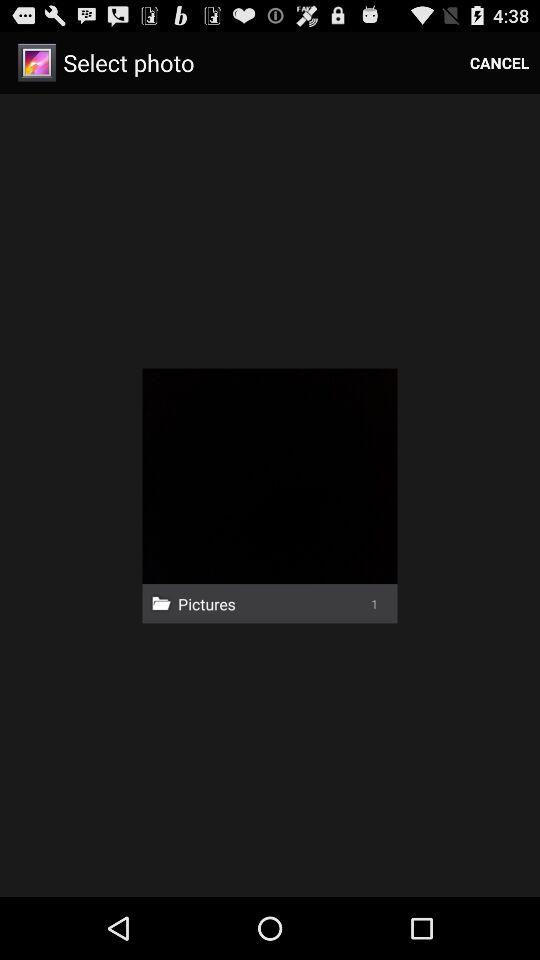Which photo was selected?
When the provided information is insufficient, respond with <no answer>. <no answer> 